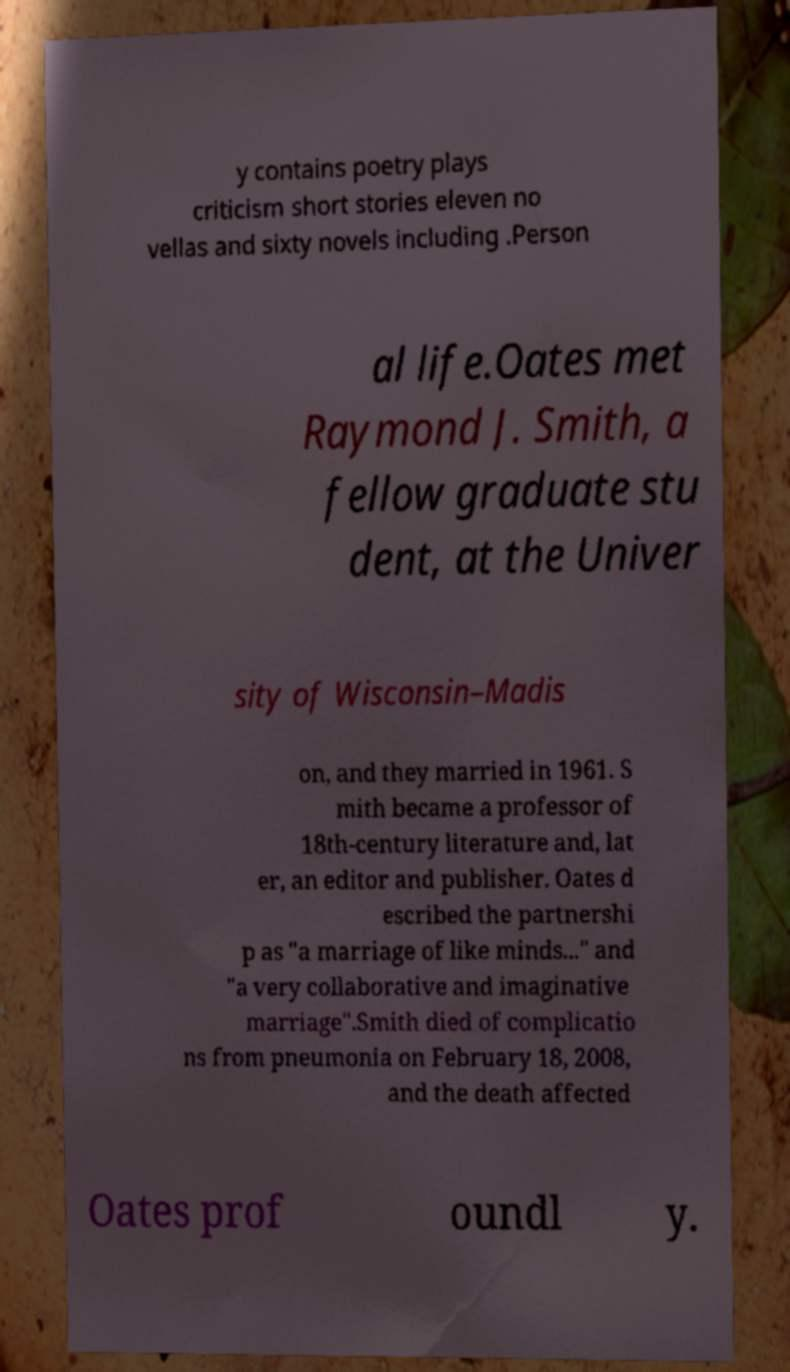Can you accurately transcribe the text from the provided image for me? y contains poetry plays criticism short stories eleven no vellas and sixty novels including .Person al life.Oates met Raymond J. Smith, a fellow graduate stu dent, at the Univer sity of Wisconsin–Madis on, and they married in 1961. S mith became a professor of 18th-century literature and, lat er, an editor and publisher. Oates d escribed the partnershi p as "a marriage of like minds..." and "a very collaborative and imaginative marriage".Smith died of complicatio ns from pneumonia on February 18, 2008, and the death affected Oates prof oundl y. 